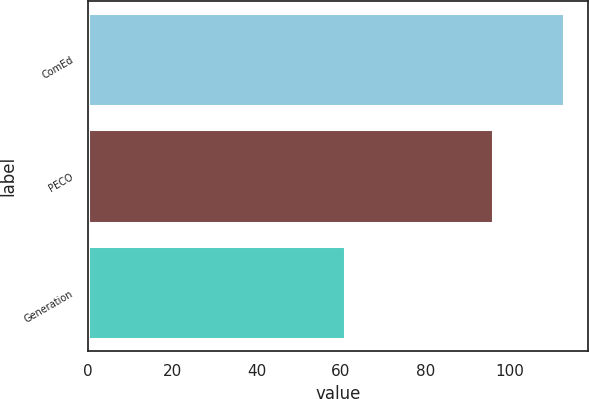<chart> <loc_0><loc_0><loc_500><loc_500><bar_chart><fcel>ComEd<fcel>PECO<fcel>Generation<nl><fcel>113<fcel>96<fcel>61<nl></chart> 